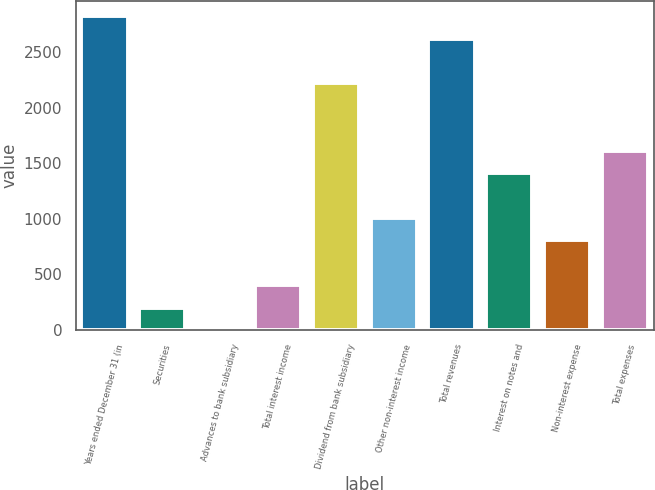<chart> <loc_0><loc_0><loc_500><loc_500><bar_chart><fcel>Years ended December 31 (in<fcel>Securities<fcel>Advances to bank subsidiary<fcel>Total interest income<fcel>Dividend from bank subsidiary<fcel>Other non-interest income<fcel>Total revenues<fcel>Interest on notes and<fcel>Non-interest expense<fcel>Total expenses<nl><fcel>2822<fcel>202.5<fcel>1<fcel>404<fcel>2217.5<fcel>1008.5<fcel>2620.5<fcel>1411.5<fcel>807<fcel>1613<nl></chart> 